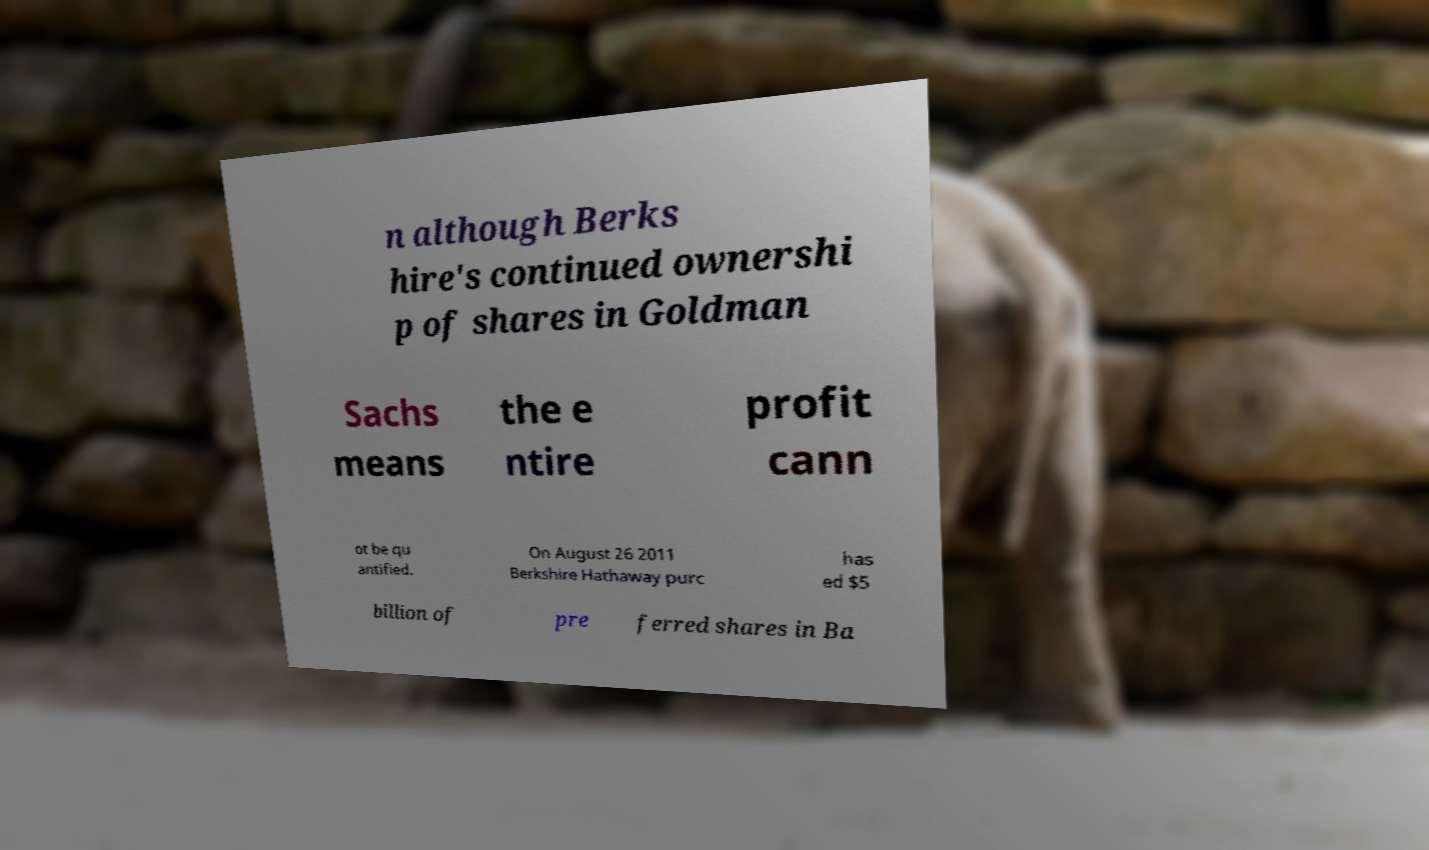What messages or text are displayed in this image? I need them in a readable, typed format. n although Berks hire's continued ownershi p of shares in Goldman Sachs means the e ntire profit cann ot be qu antified. On August 26 2011 Berkshire Hathaway purc has ed $5 billion of pre ferred shares in Ba 